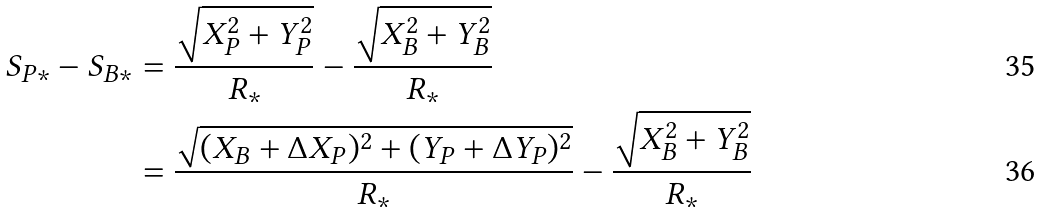Convert formula to latex. <formula><loc_0><loc_0><loc_500><loc_500>S _ { P * } - S _ { B * } & = \frac { \sqrt { X _ { P } ^ { 2 } + Y _ { P } ^ { 2 } } } { R _ { * } } - \frac { \sqrt { X _ { B } ^ { 2 } + Y _ { B } ^ { 2 } } } { R _ { * } } \\ \quad & = \frac { \sqrt { ( X _ { B } + \Delta X _ { P } ) ^ { 2 } + ( Y _ { P } + \Delta Y _ { P } ) ^ { 2 } } } { R _ { * } } - \frac { \sqrt { X _ { B } ^ { 2 } + Y _ { B } ^ { 2 } } } { R _ { * } }</formula> 